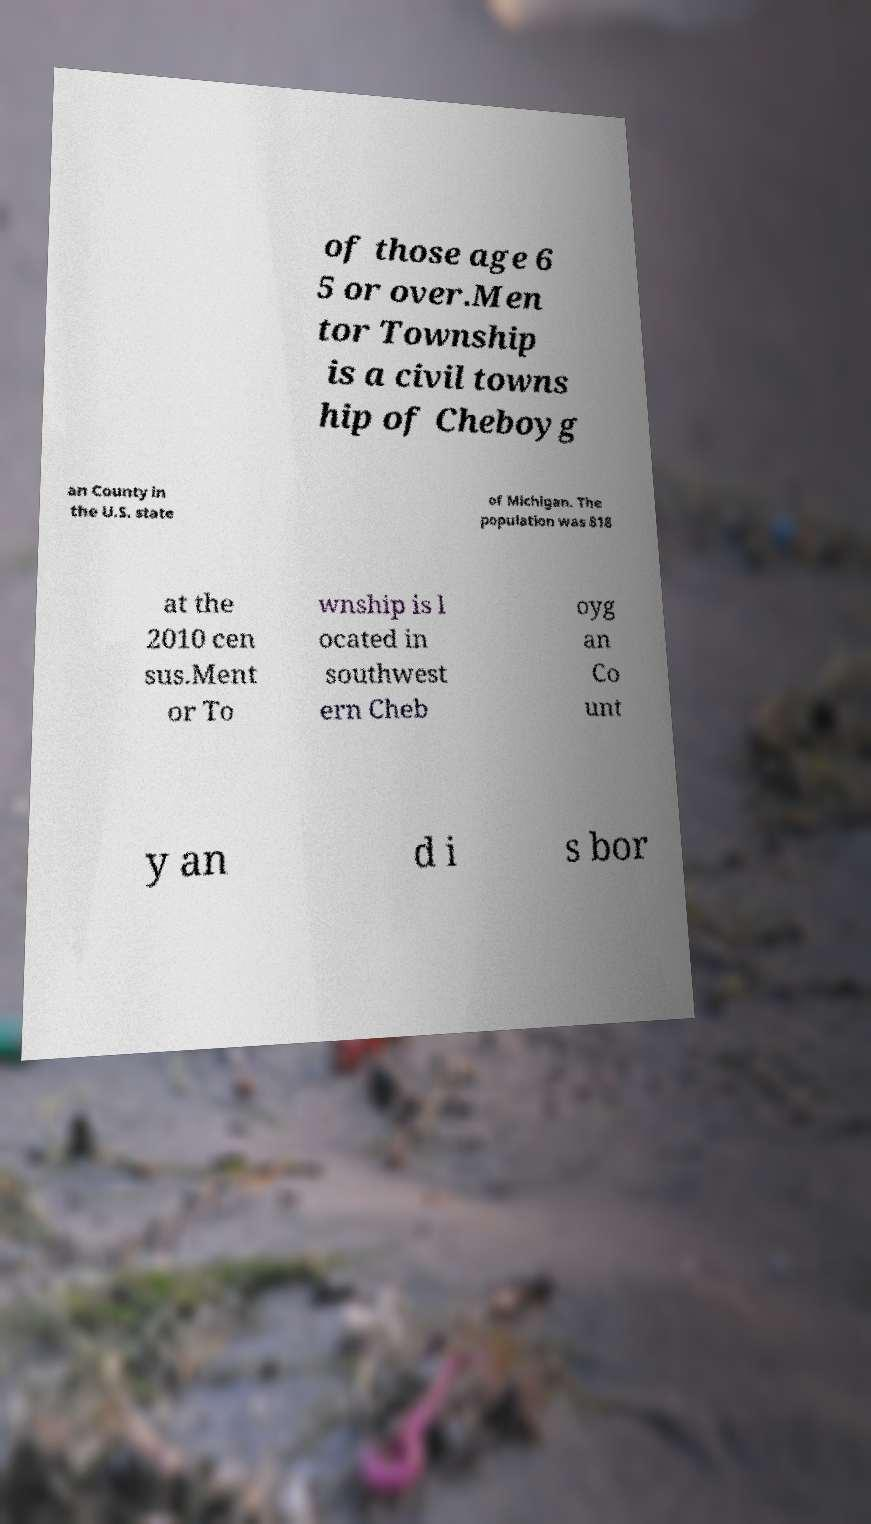Can you accurately transcribe the text from the provided image for me? of those age 6 5 or over.Men tor Township is a civil towns hip of Cheboyg an County in the U.S. state of Michigan. The population was 818 at the 2010 cen sus.Ment or To wnship is l ocated in southwest ern Cheb oyg an Co unt y an d i s bor 